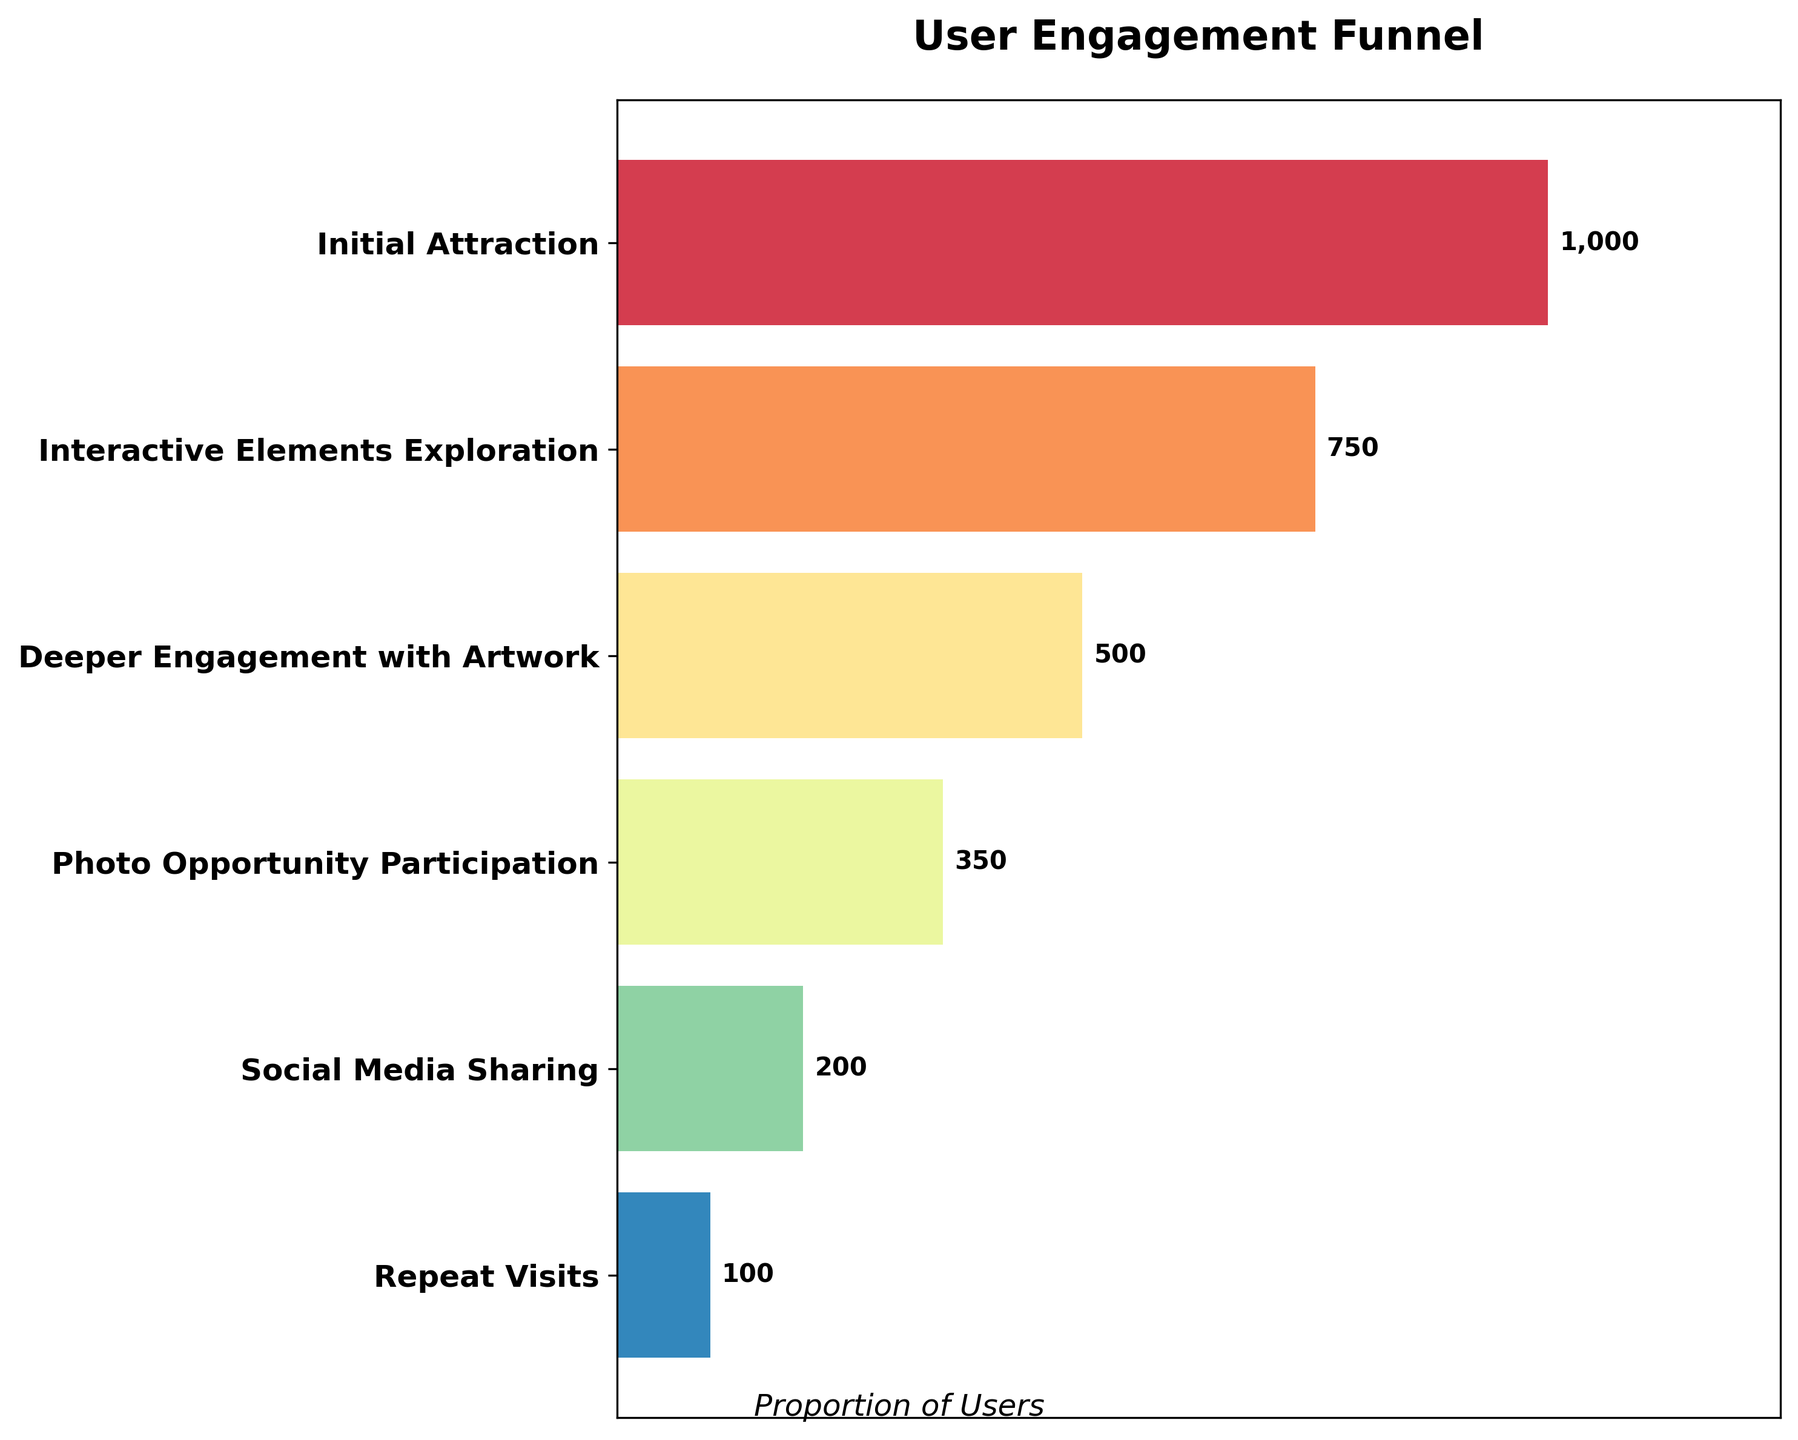How many stages are included in the funnel chart? The figure has y-ticks representing the stages. Counting them will give the total number of stages. There are 6 stages shown: Initial Attraction, Interactive Elements Exploration, Deeper Engagement with Artwork, Photo Opportunity Participation, Social Media Sharing, and Repeat Visits.
Answer: 6 What is the title of the funnel chart? The title of the chart is displayed prominently at the top of the figure, indicating the focus of the visual representation.
Answer: User Engagement Funnel Which stage has the highest number of users? The bar corresponding to the highest user count will be the widest. The widest bar is for the "Initial Attraction" stage, which occupies the top position in the funnel.
Answer: Initial Attraction What is the user count at the "Photo Opportunity Participation" stage? The user count is shown at the end of each bar. For the "Photo Opportunity Participation" stage, the count is indicated as 350 users.
Answer: 350 What is the percentage decrease in user count from the "Initial Attraction" to "Repeat Visits" stage? First, find the difference in user counts between the two stages: 1000 - 100 = 900. Then, divide by the initial count and multiply by 100 to find the percentage: (900/1000) * 100 = 90%.
Answer: 90% Which stages experience the largest drop in user count? Compare the decrease in user count between each consecutive stage. The largest drop is between "Initial Attraction" (1000) and "Interactive Elements Exploration" (750), a reduction of 250 users.
Answer: Initial Attraction to Interactive Elements Exploration What is the total user drop from "Initial Attraction" to "Social Media Sharing"? Sum the user drops between each stage: 1000-750 = 250, 750-500 = 250, 500-350 = 150, 350-200 = 150. Adding these, 250 + 250 + 150 + 150 = 800.
Answer: 800 How does the "Social Media Sharing" user count compare to "Deeper Engagement with Artwork"? Compare the user counts: "Social Media Sharing" has 200 users, while "Deeper Engagement with Artwork" has 500 users. 200 is less than 500.
Answer: Less Which stages have less than 500 users? Identify stages with user counts below 500: "Photo Opportunity Participation" (350), "Social Media Sharing" (200), and "Repeat Visits" (100).
Answer: Photo Opportunity Participation, Social Media Sharing, Repeat Visits 